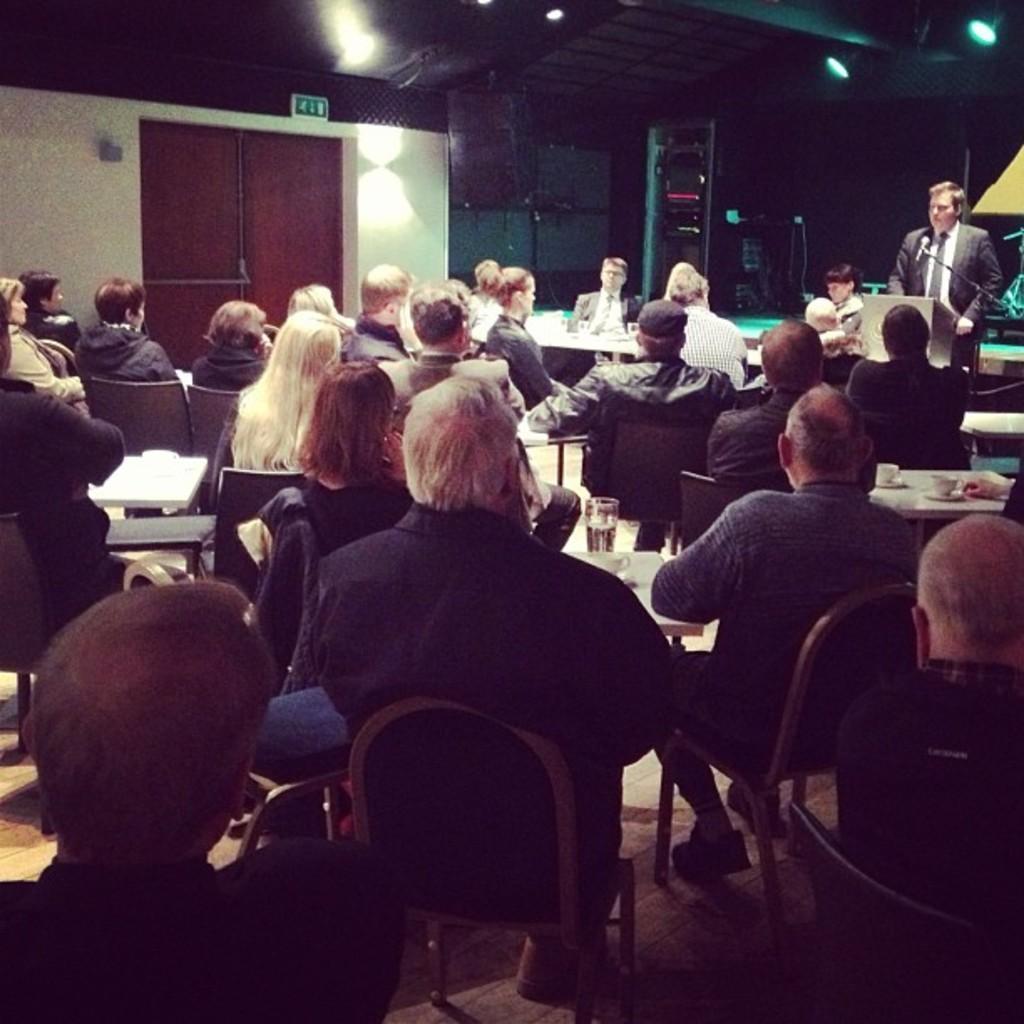Please provide a concise description of this image. In this image I can see a group of people are sitting on a chair in front of a table. I can also see there is a man is standing in front of a microphone and a podium. 